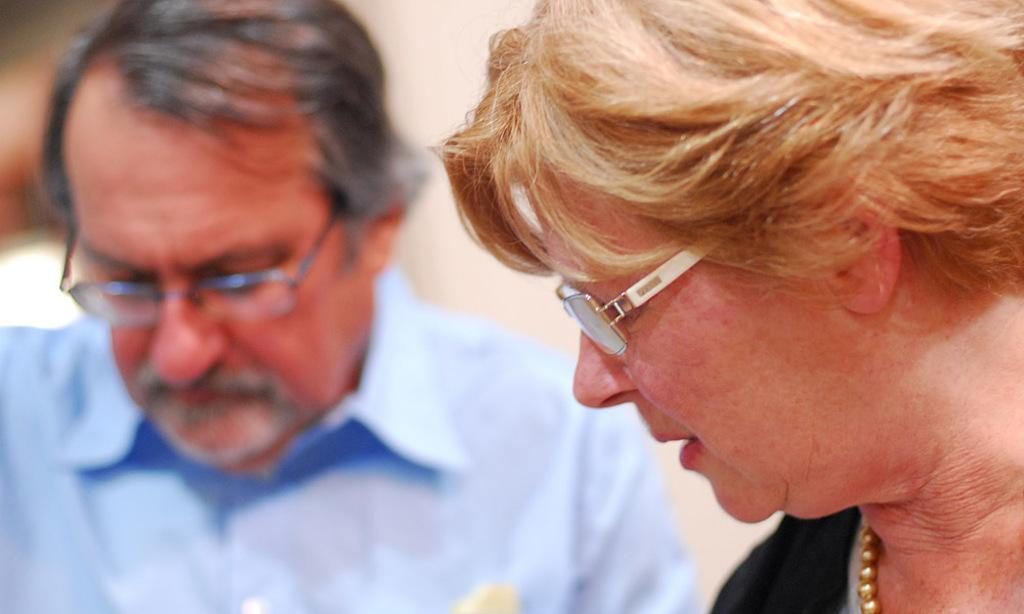What is the gender of the person in the image? There is a man and a woman in the image. What accessory is worn by both the man and the woman in the image? Both the man and the woman are wearing spectacles. Can you describe the background of the image? The background of the image is blurred. What type of marble is being used as a table in the image? There is no marble table present in the image. What class is the man teaching in the image? There is no indication of a class or teaching in the image. 